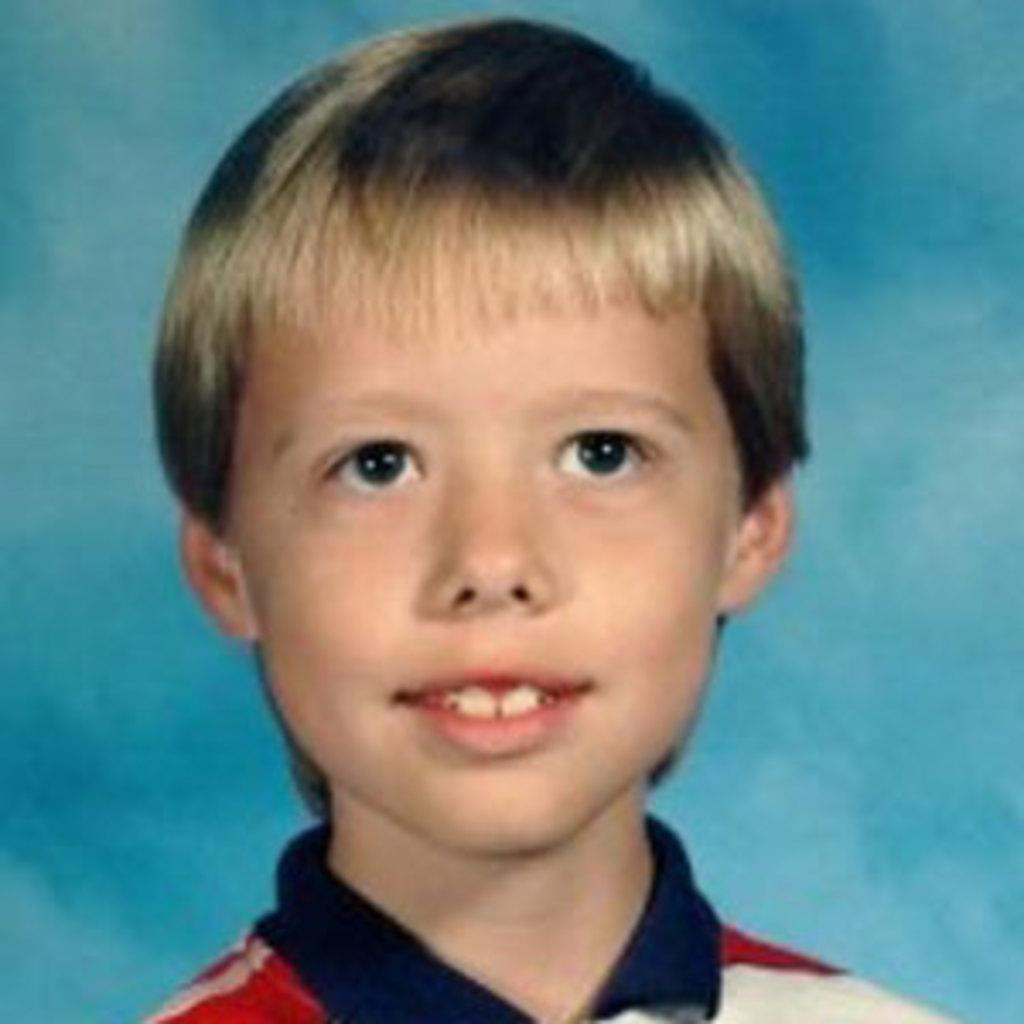What is the main subject of the image? There is a boy in the image. What is the boy's facial expression? The boy is smiling. What color is the background of the image? The background of the image is blue. What type of crate is the boy sitting on in the image? There is no crate present in the image; the boy is not sitting on anything. What flavor of cake can be seen in the image? There is no cake present in the image. 